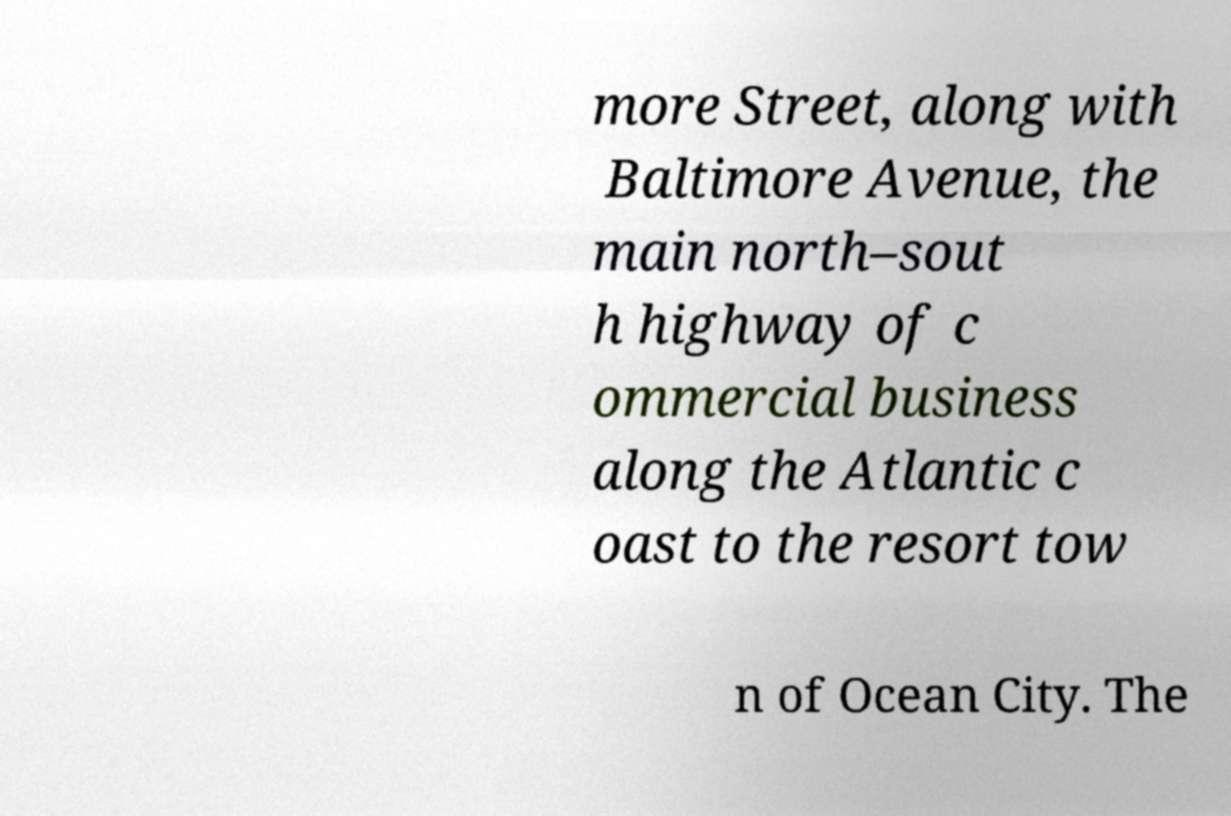There's text embedded in this image that I need extracted. Can you transcribe it verbatim? more Street, along with Baltimore Avenue, the main north–sout h highway of c ommercial business along the Atlantic c oast to the resort tow n of Ocean City. The 